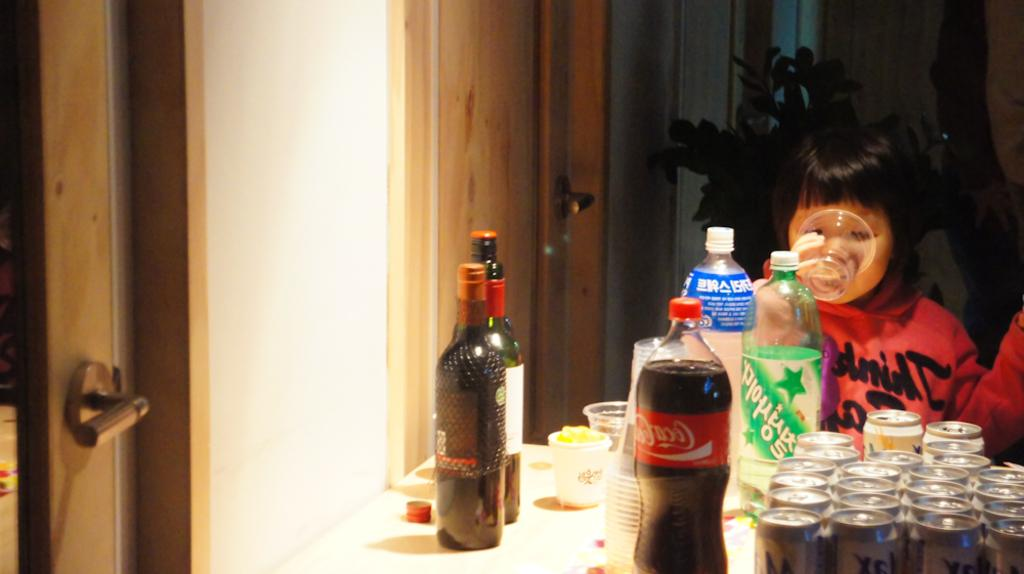What is the kid doing in the image? The kid is sitting on a chair and drinking water. What objects can be seen on the table in the image? There are bottles, tins, and cups on the table. Where is the door located in the image? There is a door in the image. What can be seen in the distance in the image? There is a plant visible in the distance. What type of minister is present in the image? There is no minister present in the image. What idea does the plant in the distance represent in the image? The image does not convey any specific ideas or concepts related to the plant; it is simply a plant visible in the distance. 